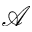<formula> <loc_0><loc_0><loc_500><loc_500>\ m a t h s c r { A }</formula> 